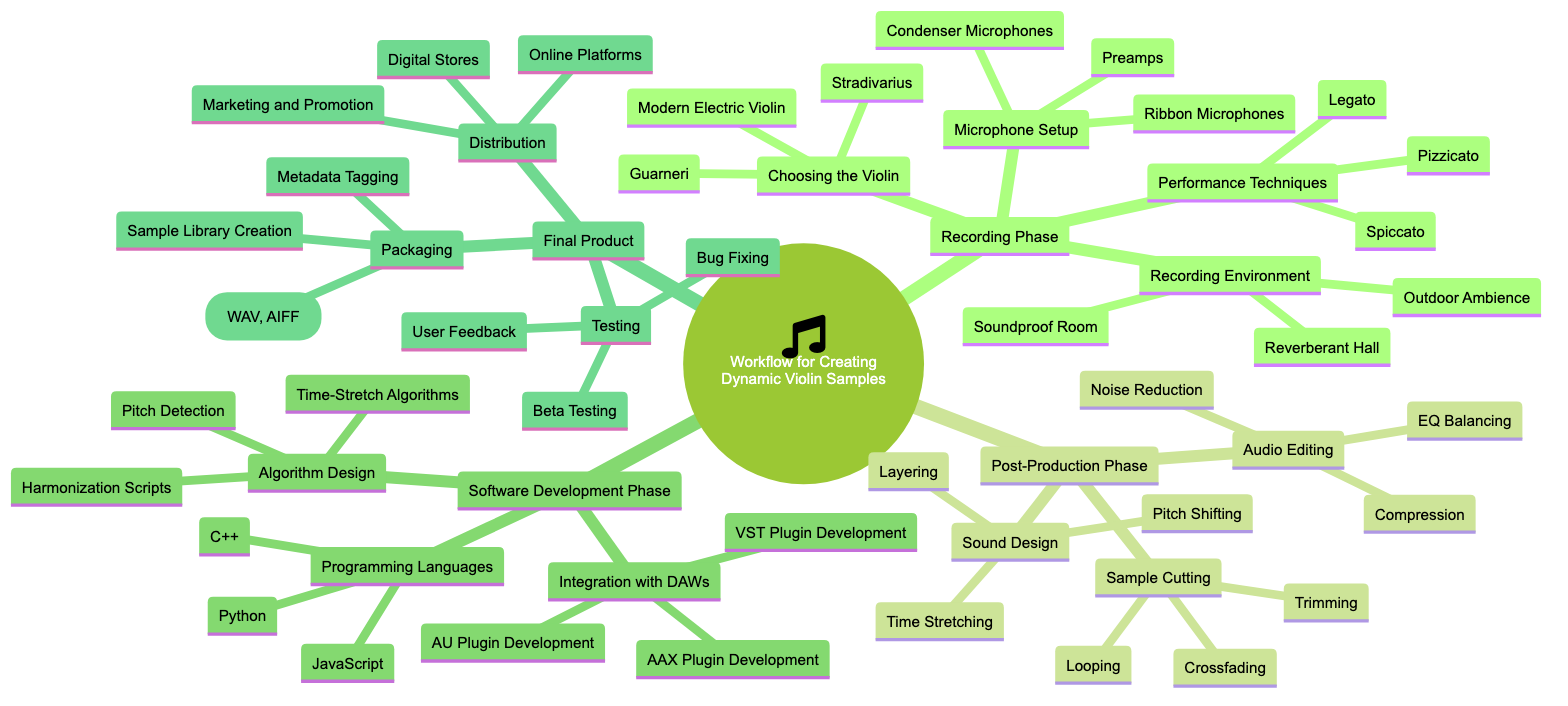What are the three options for "Choosing the Violin"? The diagram lists "Stradivarius," "Guarneri," and "Modern Electric Violin" as the three options under the "Choosing the Violin" node in the "Recording Phase."
Answer: Stradivarius, Guarneri, Modern Electric Violin How many main phases are identified in this workflow? By examining the top-level nodes in the mind map, we see there are four main phases: "Recording Phase," "Post-Production Phase," "Software Development Phase," and "Final Product." Therefore, the total count is four.
Answer: 4 What technique is listed under "Performance Techniques" for playing the violin? The diagram shows "Legato," "Pizzicato," and "Spiccato" as the techniques listed under the "Performance Techniques" node. Thus, the question focuses on one of the named techniques, which is "Legato."
Answer: Legato Which programming language is mentioned for the "Software Development Phase"? Under the "Software Development Phase," a specific node mentions "Programming Languages," which includes "C++," "Python," and "JavaScript." Therefore, any of these three could answer the question, but one example is "C++."
Answer: C++ What is the final step in the "Final Product" phase? The final node under "Final Product" is "Distribution," which lists subcategories including "Digital Stores," "Online Platforms," and "Marketing and Promotion." Hence, "Distribution" represents the last step in this phase.
Answer: Distribution What type of microphones are mentioned in the "Microphone Setup"? Within the "Microphone Setup" node of the "Recording Phase," it lists "Condenser Microphones," "Ribbon Microphones," and "Preamps." Hence, one of these options, specifically "Condenser Microphones," answers the question.
Answer: Condenser Microphones How many options are there for "Sound Design"? The "Sound Design" node under the "Post-Production Phase" lists three techniques: "Pitch Shifting," "Time Stretching," and "Layering." Thus, the total number of options available is three.
Answer: 3 In which phase does "Beta Testing" occur? "Beta Testing" is listed under the "Testing" node, which is a part of the "Final Product" phase. Therefore, the phase containing "Beta Testing" is indeed "Final Product."
Answer: Final Product What are the two components needed for "Integration with DAWs"? The node titled "Integration with DAWs" in the "Software Development Phase" lists three components: "VST Plugin Development," "AU Plugin Development," and "AAX Plugin Development." Hence, one of the components can be mentioned, such as "VST Plugin Development."
Answer: VST Plugin Development 